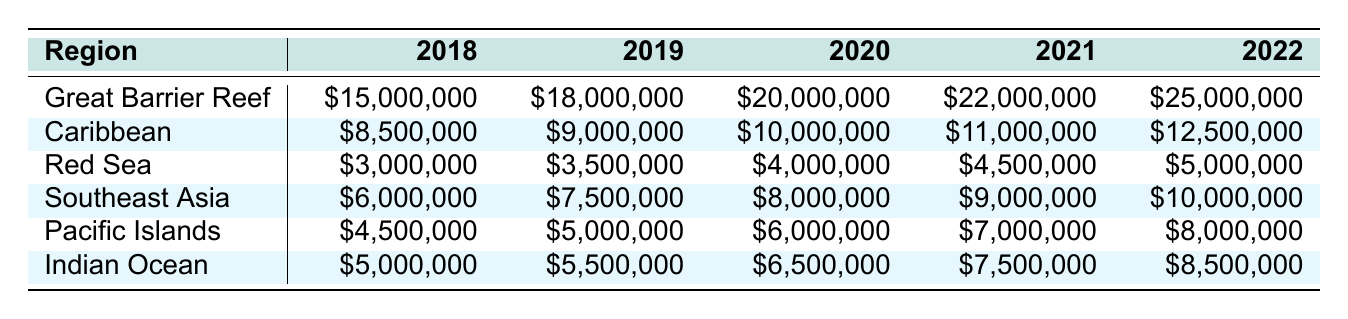What was the funding allocation for the Caribbean in 2020? The table shows that the funding allocation for the Caribbean in 2020 is $10,000,000.
Answer: $10,000,000 Which region received the highest funding in 2021? By comparing the values in the 2021 column, the Great Barrier Reef received the highest funding of $22,000,000.
Answer: Great Barrier Reef What is the total funding allocated to Southeast Asia from 2018 to 2022? Adding the funding for Southeast Asia over the five years: $6,000,000 + $7,500,000 + $8,000,000 + $9,000,000 + $10,000,000 gives a total of $40,500,000.
Answer: $40,500,000 Did the funding for the Red Sea increase every year from 2018 to 2022? Checking each year, the allocations for the Red Sea are $3,000,000, $3,500,000, $4,000,000, $4,500,000, and $5,000,000, which shows a consistent increase each year.
Answer: Yes What is the average funding allocation for the Indian Ocean across the five years? The funding allocations for the Indian Ocean are: $5,000,000, $5,500,000, $6,500,000, $7,500,000, and $8,500,000. The total is $33,000,000, and dividing by 5 gives an average of $6,600,000.
Answer: $6,600,000 How much more funding did the Great Barrier Reef receive in 2022 compared to 2018? The allocation for the Great Barrier Reef in 2022 is $25,000,000, and in 2018 it was $15,000,000. The difference is $25,000,000 - $15,000,000 = $10,000,000.
Answer: $10,000,000 What was the overall trend in funding for the Pacific Islands from 2018 to 2022? The funding for the Pacific Islands increased from $4,500,000 in 2018 to $8,000,000 in 2022, indicating a consistent upward trend over the five years.
Answer: Increasing Is the total funding for the Caribbean and Red Sea in 2021 greater than that of the Great Barrier Reef in the same year? In 2021, the Caribbean received $11,000,000 and the Red Sea received $4,500,000, totaling $15,500,000. The Great Barrier Reef received $22,000,000, which is greater.
Answer: No What is the percentage increase in funding for the Great Barrier Reef from 2018 to 2022? The funding for the Great Barrier Reef increased from $15,000,000 in 2018 to $25,000,000 in 2022. The increase is $25,000,000 - $15,000,000 = $10,000,000. The percentage increase is ($10,000,000/$15,000,000) * 100 = 66.67%.
Answer: 66.67% 